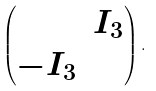<formula> <loc_0><loc_0><loc_500><loc_500>\begin{pmatrix} & I _ { 3 } \\ - I _ { 3 } & \end{pmatrix} .</formula> 